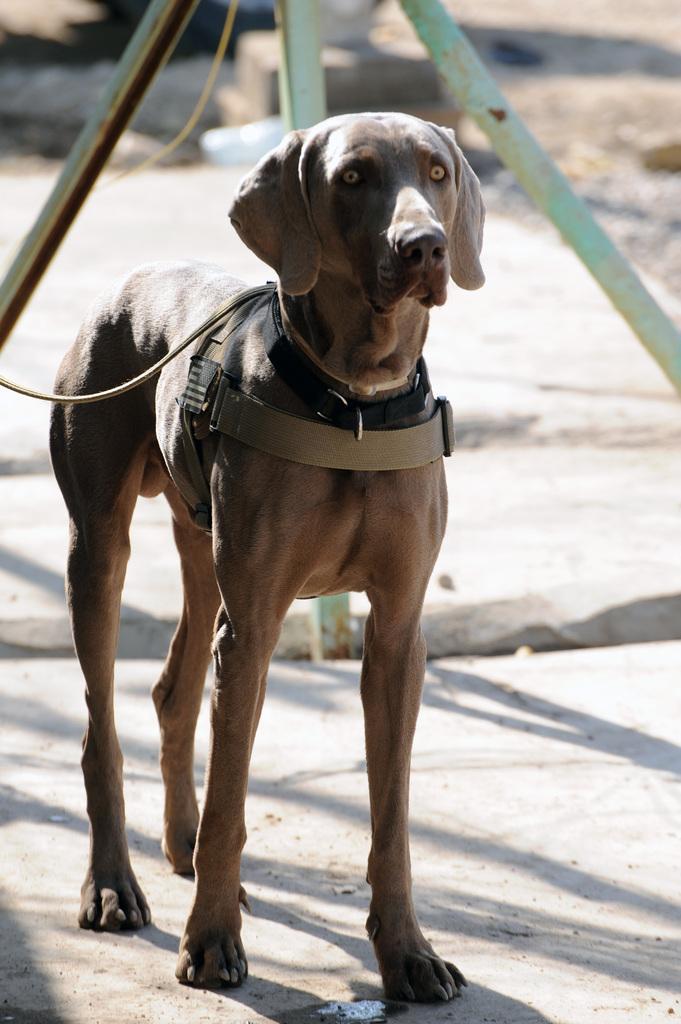Can you describe this image briefly? In front of the image there is a dog. Behind the dog there are metal rods. 